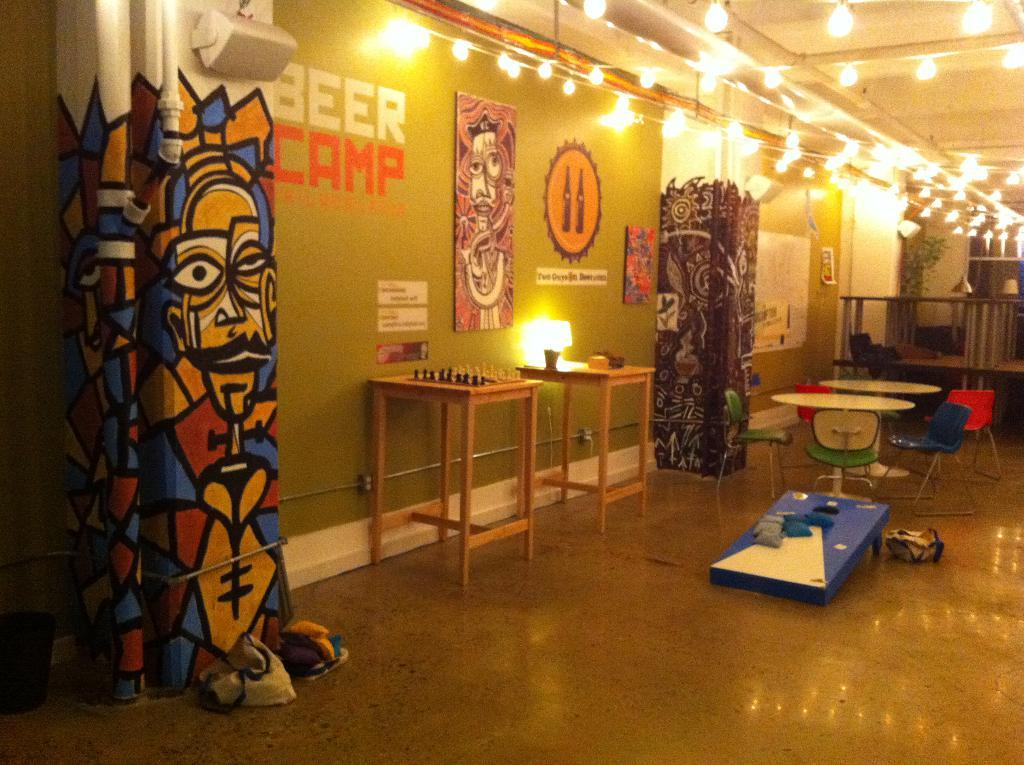<image>
Provide a brief description of the given image. the interior of a building with hanging lights and "beer camp" on one wall 